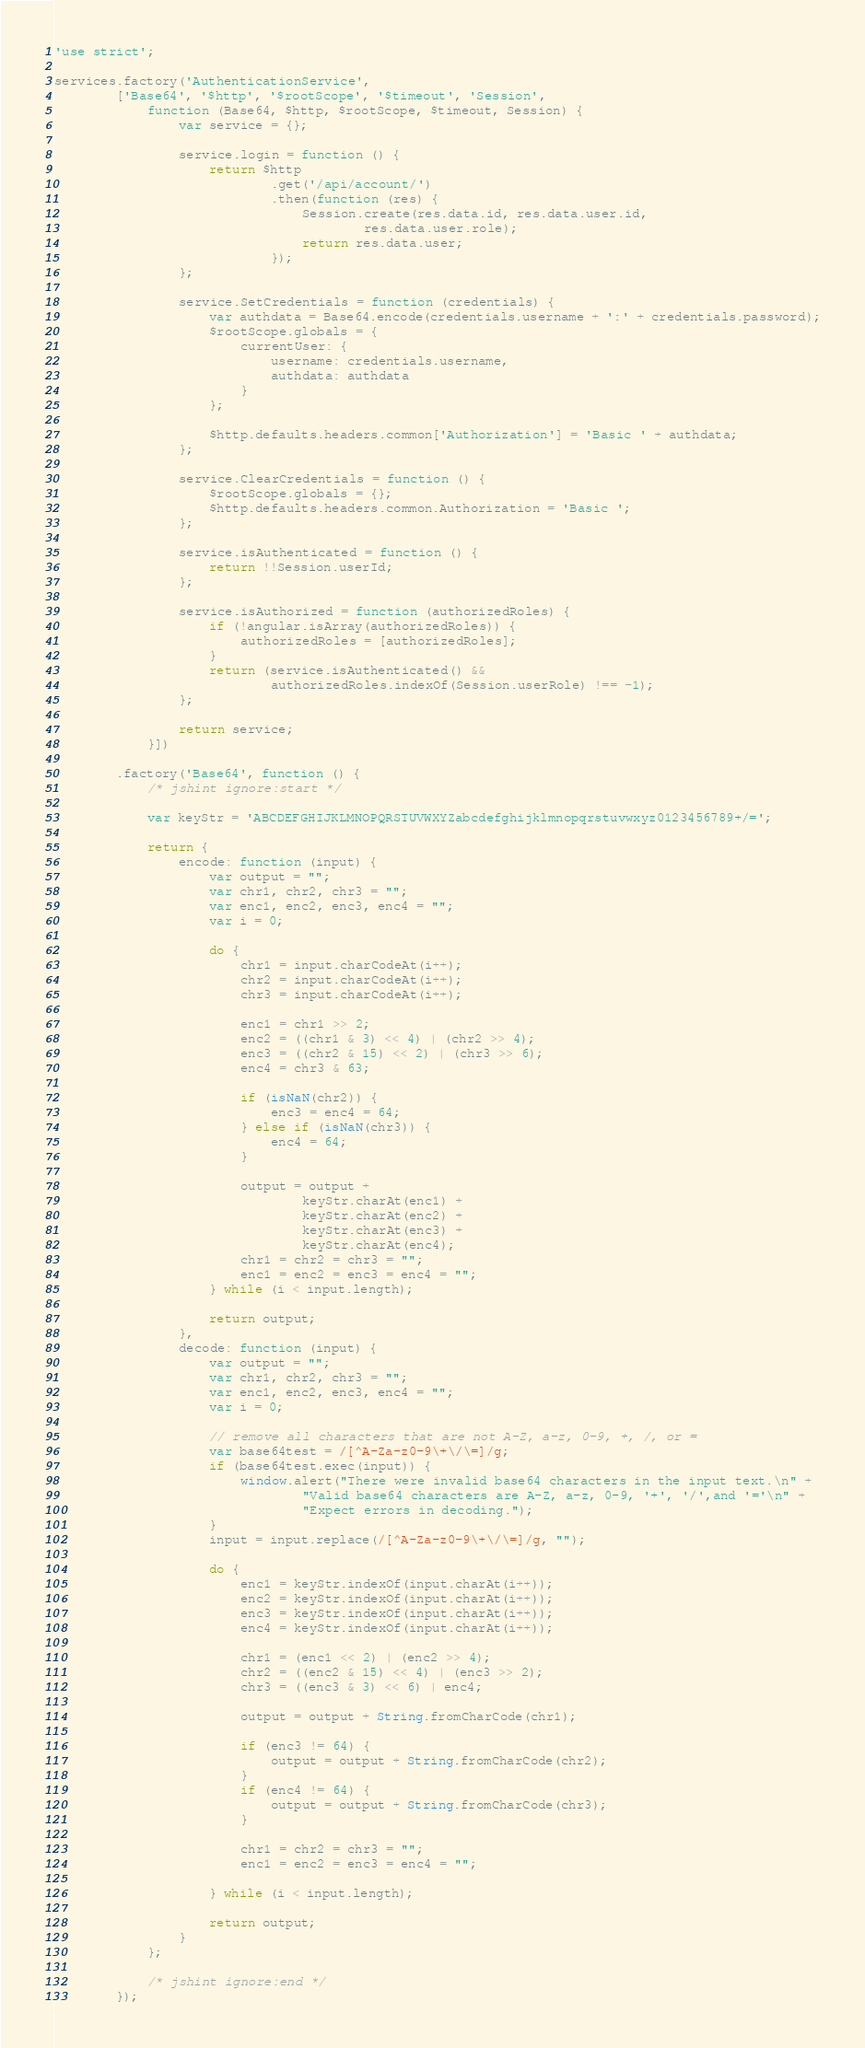Convert code to text. <code><loc_0><loc_0><loc_500><loc_500><_JavaScript_>'use strict';

services.factory('AuthenticationService',
        ['Base64', '$http', '$rootScope', '$timeout', 'Session',
            function (Base64, $http, $rootScope, $timeout, Session) {
                var service = {};

                service.login = function () {
                    return $http
                            .get('/api/account/')
                            .then(function (res) {
                                Session.create(res.data.id, res.data.user.id,
                                        res.data.user.role);
                                return res.data.user;
                            });
                };

                service.SetCredentials = function (credentials) {
                    var authdata = Base64.encode(credentials.username + ':' + credentials.password);
                    $rootScope.globals = {
                        currentUser: {
                            username: credentials.username,
                            authdata: authdata
                        }
                    };

                    $http.defaults.headers.common['Authorization'] = 'Basic ' + authdata;
                };

                service.ClearCredentials = function () {
                    $rootScope.globals = {};
                    $http.defaults.headers.common.Authorization = 'Basic ';
                };

                service.isAuthenticated = function () {
                    return !!Session.userId;
                };

                service.isAuthorized = function (authorizedRoles) {
                    if (!angular.isArray(authorizedRoles)) {
                        authorizedRoles = [authorizedRoles];
                    }
                    return (service.isAuthenticated() &&
                            authorizedRoles.indexOf(Session.userRole) !== -1);
                };

                return service;
            }])

        .factory('Base64', function () {
            /* jshint ignore:start */

            var keyStr = 'ABCDEFGHIJKLMNOPQRSTUVWXYZabcdefghijklmnopqrstuvwxyz0123456789+/=';

            return {
                encode: function (input) {
                    var output = "";
                    var chr1, chr2, chr3 = "";
                    var enc1, enc2, enc3, enc4 = "";
                    var i = 0;

                    do {
                        chr1 = input.charCodeAt(i++);
                        chr2 = input.charCodeAt(i++);
                        chr3 = input.charCodeAt(i++);

                        enc1 = chr1 >> 2;
                        enc2 = ((chr1 & 3) << 4) | (chr2 >> 4);
                        enc3 = ((chr2 & 15) << 2) | (chr3 >> 6);
                        enc4 = chr3 & 63;

                        if (isNaN(chr2)) {
                            enc3 = enc4 = 64;
                        } else if (isNaN(chr3)) {
                            enc4 = 64;
                        }

                        output = output +
                                keyStr.charAt(enc1) +
                                keyStr.charAt(enc2) +
                                keyStr.charAt(enc3) +
                                keyStr.charAt(enc4);
                        chr1 = chr2 = chr3 = "";
                        enc1 = enc2 = enc3 = enc4 = "";
                    } while (i < input.length);

                    return output;
                },
                decode: function (input) {
                    var output = "";
                    var chr1, chr2, chr3 = "";
                    var enc1, enc2, enc3, enc4 = "";
                    var i = 0;

                    // remove all characters that are not A-Z, a-z, 0-9, +, /, or =
                    var base64test = /[^A-Za-z0-9\+\/\=]/g;
                    if (base64test.exec(input)) {
                        window.alert("There were invalid base64 characters in the input text.\n" +
                                "Valid base64 characters are A-Z, a-z, 0-9, '+', '/',and '='\n" +
                                "Expect errors in decoding.");
                    }
                    input = input.replace(/[^A-Za-z0-9\+\/\=]/g, "");

                    do {
                        enc1 = keyStr.indexOf(input.charAt(i++));
                        enc2 = keyStr.indexOf(input.charAt(i++));
                        enc3 = keyStr.indexOf(input.charAt(i++));
                        enc4 = keyStr.indexOf(input.charAt(i++));

                        chr1 = (enc1 << 2) | (enc2 >> 4);
                        chr2 = ((enc2 & 15) << 4) | (enc3 >> 2);
                        chr3 = ((enc3 & 3) << 6) | enc4;

                        output = output + String.fromCharCode(chr1);

                        if (enc3 != 64) {
                            output = output + String.fromCharCode(chr2);
                        }
                        if (enc4 != 64) {
                            output = output + String.fromCharCode(chr3);
                        }

                        chr1 = chr2 = chr3 = "";
                        enc1 = enc2 = enc3 = enc4 = "";

                    } while (i < input.length);

                    return output;
                }
            };

            /* jshint ignore:end */
        });</code> 